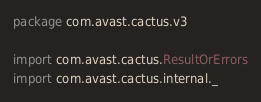Convert code to text. <code><loc_0><loc_0><loc_500><loc_500><_Scala_>package com.avast.cactus.v3

import com.avast.cactus.ResultOrErrors
import com.avast.cactus.internal._</code> 